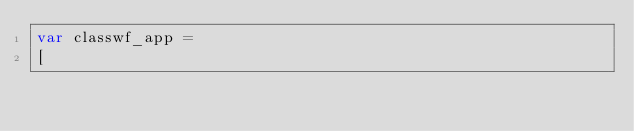Convert code to text. <code><loc_0><loc_0><loc_500><loc_500><_JavaScript_>var classwf_app =
[</code> 